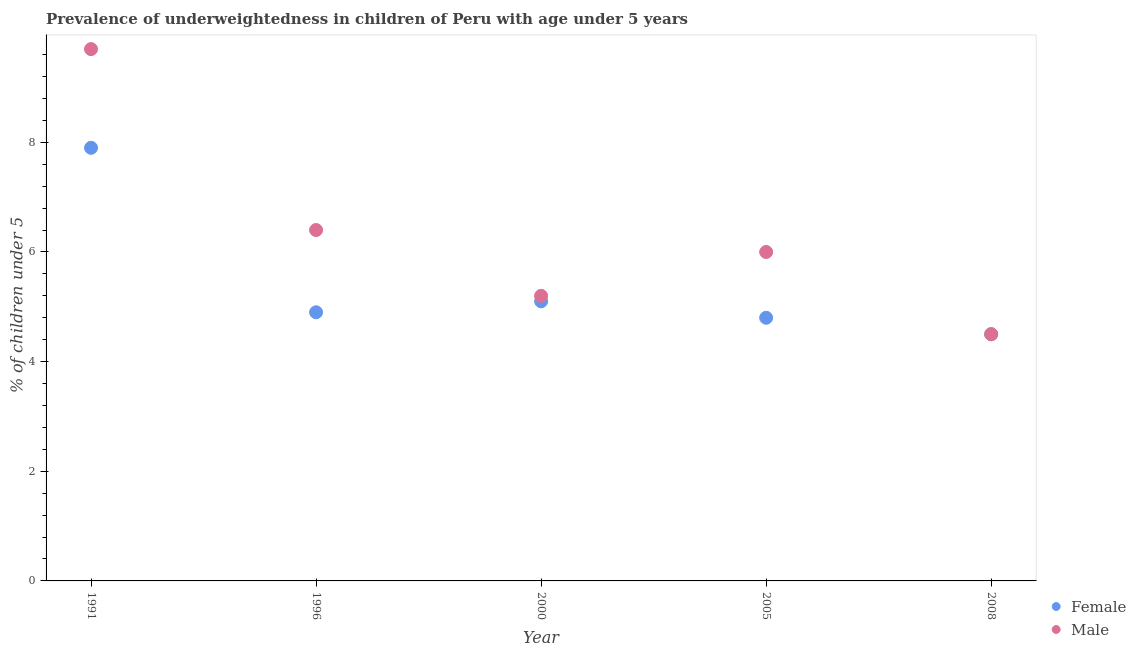How many different coloured dotlines are there?
Provide a short and direct response. 2. Is the number of dotlines equal to the number of legend labels?
Give a very brief answer. Yes. What is the percentage of underweighted female children in 1991?
Ensure brevity in your answer.  7.9. Across all years, what is the maximum percentage of underweighted female children?
Your answer should be compact. 7.9. In which year was the percentage of underweighted female children maximum?
Your answer should be compact. 1991. What is the total percentage of underweighted female children in the graph?
Offer a terse response. 27.2. What is the difference between the percentage of underweighted female children in 1996 and that in 2000?
Give a very brief answer. -0.2. What is the difference between the percentage of underweighted female children in 1996 and the percentage of underweighted male children in 2000?
Offer a very short reply. -0.3. What is the average percentage of underweighted female children per year?
Keep it short and to the point. 5.44. What is the ratio of the percentage of underweighted male children in 1996 to that in 2000?
Make the answer very short. 1.23. Is the percentage of underweighted male children in 2005 less than that in 2008?
Keep it short and to the point. No. Is the difference between the percentage of underweighted female children in 1991 and 1996 greater than the difference between the percentage of underweighted male children in 1991 and 1996?
Your answer should be compact. No. What is the difference between the highest and the second highest percentage of underweighted male children?
Make the answer very short. 3.3. What is the difference between the highest and the lowest percentage of underweighted female children?
Offer a very short reply. 3.4. In how many years, is the percentage of underweighted female children greater than the average percentage of underweighted female children taken over all years?
Your answer should be compact. 1. Is the sum of the percentage of underweighted male children in 1996 and 2008 greater than the maximum percentage of underweighted female children across all years?
Offer a terse response. Yes. Is the percentage of underweighted male children strictly greater than the percentage of underweighted female children over the years?
Your answer should be compact. No. Is the percentage of underweighted female children strictly less than the percentage of underweighted male children over the years?
Your answer should be very brief. No. How many dotlines are there?
Offer a terse response. 2. How many years are there in the graph?
Keep it short and to the point. 5. What is the difference between two consecutive major ticks on the Y-axis?
Your answer should be compact. 2. Does the graph contain any zero values?
Provide a short and direct response. No. Does the graph contain grids?
Provide a succinct answer. No. Where does the legend appear in the graph?
Offer a very short reply. Bottom right. How many legend labels are there?
Give a very brief answer. 2. What is the title of the graph?
Give a very brief answer. Prevalence of underweightedness in children of Peru with age under 5 years. Does "Attending school" appear as one of the legend labels in the graph?
Give a very brief answer. No. What is the label or title of the Y-axis?
Ensure brevity in your answer.   % of children under 5. What is the  % of children under 5 of Female in 1991?
Give a very brief answer. 7.9. What is the  % of children under 5 in Male in 1991?
Offer a terse response. 9.7. What is the  % of children under 5 of Female in 1996?
Offer a very short reply. 4.9. What is the  % of children under 5 of Male in 1996?
Offer a very short reply. 6.4. What is the  % of children under 5 in Female in 2000?
Your answer should be very brief. 5.1. What is the  % of children under 5 of Male in 2000?
Keep it short and to the point. 5.2. What is the  % of children under 5 of Female in 2005?
Your answer should be compact. 4.8. What is the  % of children under 5 in Male in 2005?
Provide a succinct answer. 6. What is the  % of children under 5 in Male in 2008?
Offer a very short reply. 4.5. Across all years, what is the maximum  % of children under 5 in Female?
Keep it short and to the point. 7.9. Across all years, what is the maximum  % of children under 5 in Male?
Keep it short and to the point. 9.7. Across all years, what is the minimum  % of children under 5 in Female?
Offer a very short reply. 4.5. Across all years, what is the minimum  % of children under 5 of Male?
Make the answer very short. 4.5. What is the total  % of children under 5 in Female in the graph?
Your answer should be very brief. 27.2. What is the total  % of children under 5 in Male in the graph?
Provide a short and direct response. 31.8. What is the difference between the  % of children under 5 in Male in 1991 and that in 2000?
Provide a short and direct response. 4.5. What is the difference between the  % of children under 5 of Female in 1991 and that in 2005?
Ensure brevity in your answer.  3.1. What is the difference between the  % of children under 5 in Male in 1991 and that in 2008?
Keep it short and to the point. 5.2. What is the difference between the  % of children under 5 in Male in 1996 and that in 2000?
Give a very brief answer. 1.2. What is the difference between the  % of children under 5 in Female in 1996 and that in 2005?
Offer a terse response. 0.1. What is the difference between the  % of children under 5 of Male in 1996 and that in 2005?
Offer a terse response. 0.4. What is the difference between the  % of children under 5 of Female in 1996 and that in 2008?
Offer a very short reply. 0.4. What is the difference between the  % of children under 5 of Male in 1996 and that in 2008?
Keep it short and to the point. 1.9. What is the difference between the  % of children under 5 of Female in 1991 and the  % of children under 5 of Male in 1996?
Make the answer very short. 1.5. What is the difference between the  % of children under 5 in Female in 1991 and the  % of children under 5 in Male in 2005?
Ensure brevity in your answer.  1.9. What is the difference between the  % of children under 5 of Female in 2000 and the  % of children under 5 of Male in 2005?
Make the answer very short. -0.9. What is the difference between the  % of children under 5 of Female in 2005 and the  % of children under 5 of Male in 2008?
Provide a succinct answer. 0.3. What is the average  % of children under 5 in Female per year?
Keep it short and to the point. 5.44. What is the average  % of children under 5 in Male per year?
Your answer should be compact. 6.36. In the year 1991, what is the difference between the  % of children under 5 of Female and  % of children under 5 of Male?
Make the answer very short. -1.8. In the year 1996, what is the difference between the  % of children under 5 in Female and  % of children under 5 in Male?
Keep it short and to the point. -1.5. In the year 2008, what is the difference between the  % of children under 5 of Female and  % of children under 5 of Male?
Provide a short and direct response. 0. What is the ratio of the  % of children under 5 of Female in 1991 to that in 1996?
Your response must be concise. 1.61. What is the ratio of the  % of children under 5 of Male in 1991 to that in 1996?
Your answer should be compact. 1.52. What is the ratio of the  % of children under 5 of Female in 1991 to that in 2000?
Give a very brief answer. 1.55. What is the ratio of the  % of children under 5 of Male in 1991 to that in 2000?
Your answer should be very brief. 1.87. What is the ratio of the  % of children under 5 in Female in 1991 to that in 2005?
Your response must be concise. 1.65. What is the ratio of the  % of children under 5 in Male in 1991 to that in 2005?
Keep it short and to the point. 1.62. What is the ratio of the  % of children under 5 in Female in 1991 to that in 2008?
Provide a short and direct response. 1.76. What is the ratio of the  % of children under 5 of Male in 1991 to that in 2008?
Your answer should be compact. 2.16. What is the ratio of the  % of children under 5 in Female in 1996 to that in 2000?
Give a very brief answer. 0.96. What is the ratio of the  % of children under 5 in Male in 1996 to that in 2000?
Your answer should be very brief. 1.23. What is the ratio of the  % of children under 5 of Female in 1996 to that in 2005?
Provide a succinct answer. 1.02. What is the ratio of the  % of children under 5 of Male in 1996 to that in 2005?
Give a very brief answer. 1.07. What is the ratio of the  % of children under 5 in Female in 1996 to that in 2008?
Your answer should be compact. 1.09. What is the ratio of the  % of children under 5 of Male in 1996 to that in 2008?
Keep it short and to the point. 1.42. What is the ratio of the  % of children under 5 in Male in 2000 to that in 2005?
Give a very brief answer. 0.87. What is the ratio of the  % of children under 5 in Female in 2000 to that in 2008?
Offer a very short reply. 1.13. What is the ratio of the  % of children under 5 of Male in 2000 to that in 2008?
Your response must be concise. 1.16. What is the ratio of the  % of children under 5 of Female in 2005 to that in 2008?
Give a very brief answer. 1.07. What is the difference between the highest and the lowest  % of children under 5 of Male?
Offer a very short reply. 5.2. 